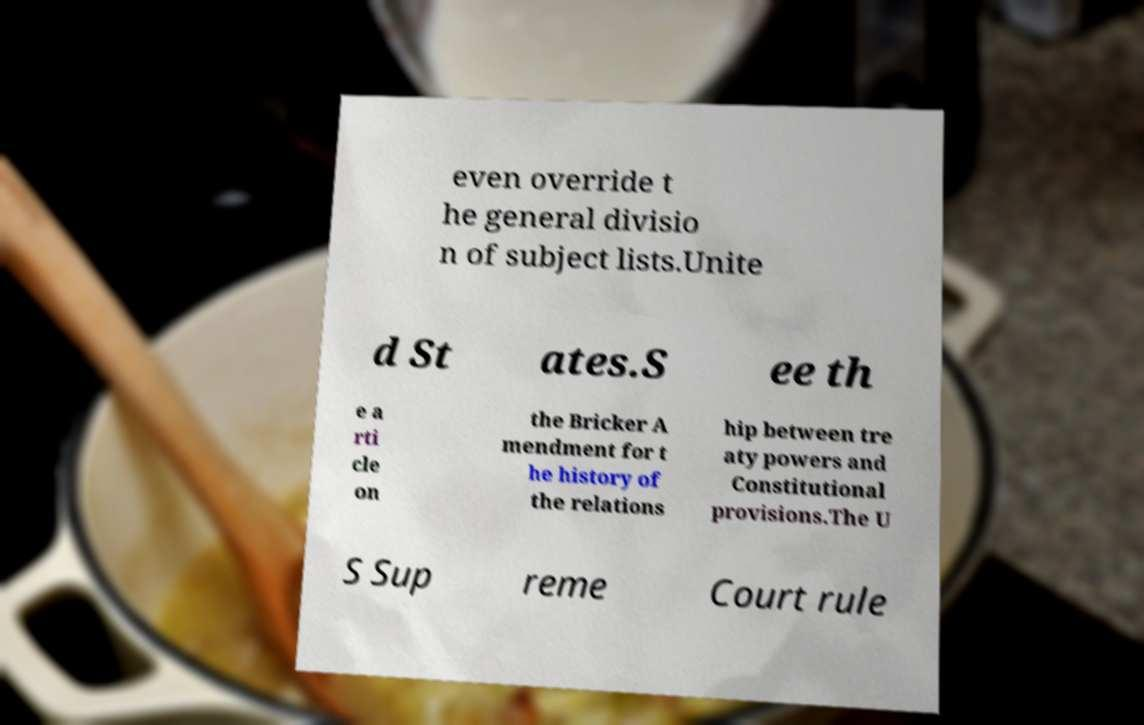What messages or text are displayed in this image? I need them in a readable, typed format. even override t he general divisio n of subject lists.Unite d St ates.S ee th e a rti cle on the Bricker A mendment for t he history of the relations hip between tre aty powers and Constitutional provisions.The U S Sup reme Court rule 